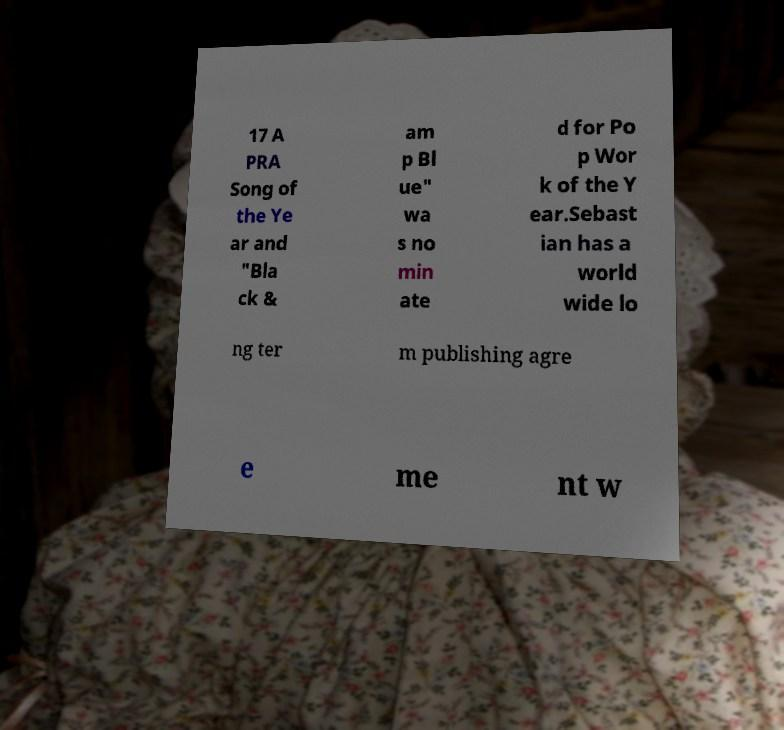Can you accurately transcribe the text from the provided image for me? 17 A PRA Song of the Ye ar and "Bla ck & am p Bl ue" wa s no min ate d for Po p Wor k of the Y ear.Sebast ian has a world wide lo ng ter m publishing agre e me nt w 